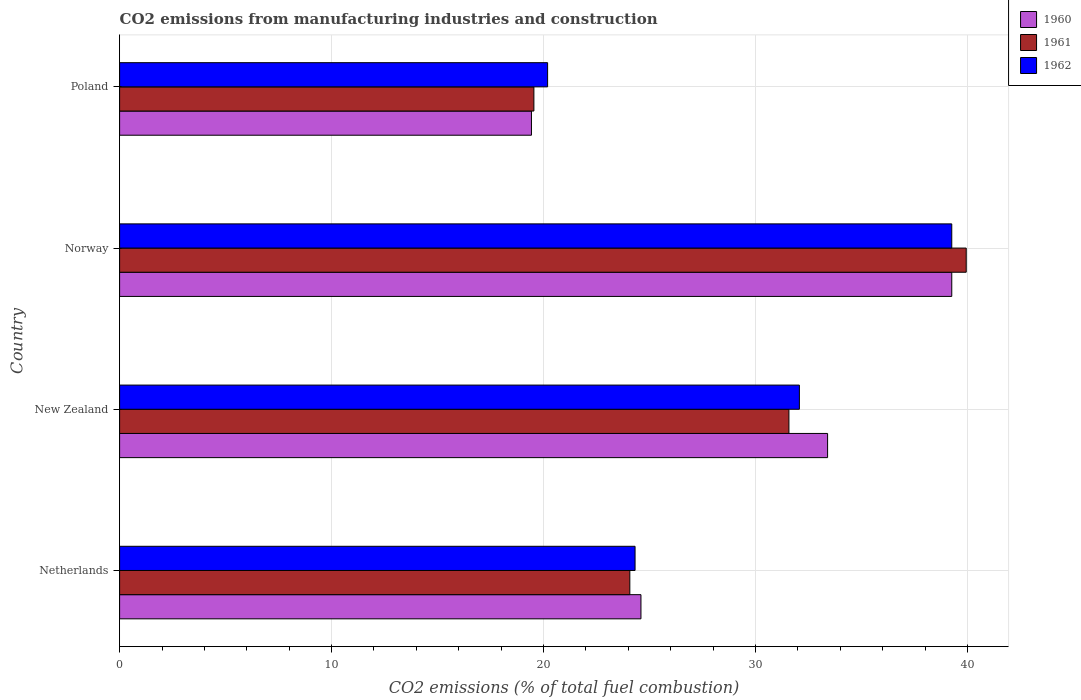How many different coloured bars are there?
Give a very brief answer. 3. How many groups of bars are there?
Your answer should be very brief. 4. How many bars are there on the 4th tick from the top?
Your answer should be compact. 3. In how many cases, is the number of bars for a given country not equal to the number of legend labels?
Offer a terse response. 0. What is the amount of CO2 emitted in 1960 in New Zealand?
Your answer should be compact. 33.4. Across all countries, what is the maximum amount of CO2 emitted in 1961?
Offer a terse response. 39.94. Across all countries, what is the minimum amount of CO2 emitted in 1960?
Make the answer very short. 19.43. In which country was the amount of CO2 emitted in 1961 maximum?
Ensure brevity in your answer.  Norway. In which country was the amount of CO2 emitted in 1962 minimum?
Keep it short and to the point. Poland. What is the total amount of CO2 emitted in 1962 in the graph?
Your response must be concise. 115.83. What is the difference between the amount of CO2 emitted in 1961 in Netherlands and that in New Zealand?
Offer a terse response. -7.5. What is the difference between the amount of CO2 emitted in 1962 in Poland and the amount of CO2 emitted in 1960 in Netherlands?
Offer a very short reply. -4.4. What is the average amount of CO2 emitted in 1962 per country?
Give a very brief answer. 28.96. What is the difference between the amount of CO2 emitted in 1962 and amount of CO2 emitted in 1960 in Poland?
Provide a short and direct response. 0.76. In how many countries, is the amount of CO2 emitted in 1960 greater than 6 %?
Ensure brevity in your answer.  4. What is the ratio of the amount of CO2 emitted in 1960 in Netherlands to that in New Zealand?
Give a very brief answer. 0.74. Is the difference between the amount of CO2 emitted in 1962 in Norway and Poland greater than the difference between the amount of CO2 emitted in 1960 in Norway and Poland?
Give a very brief answer. No. What is the difference between the highest and the second highest amount of CO2 emitted in 1960?
Keep it short and to the point. 5.86. What is the difference between the highest and the lowest amount of CO2 emitted in 1962?
Keep it short and to the point. 19.06. In how many countries, is the amount of CO2 emitted in 1962 greater than the average amount of CO2 emitted in 1962 taken over all countries?
Make the answer very short. 2. Is the sum of the amount of CO2 emitted in 1961 in New Zealand and Norway greater than the maximum amount of CO2 emitted in 1962 across all countries?
Offer a very short reply. Yes. What does the 1st bar from the bottom in Poland represents?
Ensure brevity in your answer.  1960. Is it the case that in every country, the sum of the amount of CO2 emitted in 1961 and amount of CO2 emitted in 1962 is greater than the amount of CO2 emitted in 1960?
Provide a short and direct response. Yes. How many bars are there?
Provide a succinct answer. 12. Are all the bars in the graph horizontal?
Your answer should be very brief. Yes. What is the difference between two consecutive major ticks on the X-axis?
Offer a very short reply. 10. Does the graph contain any zero values?
Your response must be concise. No. How are the legend labels stacked?
Give a very brief answer. Vertical. What is the title of the graph?
Give a very brief answer. CO2 emissions from manufacturing industries and construction. Does "1998" appear as one of the legend labels in the graph?
Make the answer very short. No. What is the label or title of the X-axis?
Make the answer very short. CO2 emissions (% of total fuel combustion). What is the label or title of the Y-axis?
Provide a short and direct response. Country. What is the CO2 emissions (% of total fuel combustion) of 1960 in Netherlands?
Your response must be concise. 24.59. What is the CO2 emissions (% of total fuel combustion) in 1961 in Netherlands?
Ensure brevity in your answer.  24.07. What is the CO2 emissions (% of total fuel combustion) in 1962 in Netherlands?
Make the answer very short. 24.32. What is the CO2 emissions (% of total fuel combustion) in 1960 in New Zealand?
Offer a terse response. 33.4. What is the CO2 emissions (% of total fuel combustion) in 1961 in New Zealand?
Provide a short and direct response. 31.57. What is the CO2 emissions (% of total fuel combustion) in 1962 in New Zealand?
Make the answer very short. 32.07. What is the CO2 emissions (% of total fuel combustion) of 1960 in Norway?
Make the answer very short. 39.26. What is the CO2 emissions (% of total fuel combustion) in 1961 in Norway?
Provide a short and direct response. 39.94. What is the CO2 emissions (% of total fuel combustion) of 1962 in Norway?
Provide a short and direct response. 39.26. What is the CO2 emissions (% of total fuel combustion) in 1960 in Poland?
Provide a succinct answer. 19.43. What is the CO2 emissions (% of total fuel combustion) in 1961 in Poland?
Keep it short and to the point. 19.54. What is the CO2 emissions (% of total fuel combustion) in 1962 in Poland?
Ensure brevity in your answer.  20.19. Across all countries, what is the maximum CO2 emissions (% of total fuel combustion) in 1960?
Your answer should be very brief. 39.26. Across all countries, what is the maximum CO2 emissions (% of total fuel combustion) of 1961?
Your answer should be compact. 39.94. Across all countries, what is the maximum CO2 emissions (% of total fuel combustion) of 1962?
Your answer should be very brief. 39.26. Across all countries, what is the minimum CO2 emissions (% of total fuel combustion) of 1960?
Provide a succinct answer. 19.43. Across all countries, what is the minimum CO2 emissions (% of total fuel combustion) of 1961?
Ensure brevity in your answer.  19.54. Across all countries, what is the minimum CO2 emissions (% of total fuel combustion) in 1962?
Provide a short and direct response. 20.19. What is the total CO2 emissions (% of total fuel combustion) in 1960 in the graph?
Keep it short and to the point. 116.68. What is the total CO2 emissions (% of total fuel combustion) of 1961 in the graph?
Keep it short and to the point. 115.12. What is the total CO2 emissions (% of total fuel combustion) of 1962 in the graph?
Keep it short and to the point. 115.83. What is the difference between the CO2 emissions (% of total fuel combustion) in 1960 in Netherlands and that in New Zealand?
Give a very brief answer. -8.8. What is the difference between the CO2 emissions (% of total fuel combustion) of 1961 in Netherlands and that in New Zealand?
Your response must be concise. -7.5. What is the difference between the CO2 emissions (% of total fuel combustion) in 1962 in Netherlands and that in New Zealand?
Make the answer very short. -7.75. What is the difference between the CO2 emissions (% of total fuel combustion) of 1960 in Netherlands and that in Norway?
Your answer should be very brief. -14.66. What is the difference between the CO2 emissions (% of total fuel combustion) of 1961 in Netherlands and that in Norway?
Make the answer very short. -15.87. What is the difference between the CO2 emissions (% of total fuel combustion) in 1962 in Netherlands and that in Norway?
Your response must be concise. -14.94. What is the difference between the CO2 emissions (% of total fuel combustion) of 1960 in Netherlands and that in Poland?
Make the answer very short. 5.17. What is the difference between the CO2 emissions (% of total fuel combustion) in 1961 in Netherlands and that in Poland?
Your answer should be very brief. 4.53. What is the difference between the CO2 emissions (% of total fuel combustion) in 1962 in Netherlands and that in Poland?
Ensure brevity in your answer.  4.13. What is the difference between the CO2 emissions (% of total fuel combustion) of 1960 in New Zealand and that in Norway?
Offer a very short reply. -5.86. What is the difference between the CO2 emissions (% of total fuel combustion) of 1961 in New Zealand and that in Norway?
Offer a terse response. -8.36. What is the difference between the CO2 emissions (% of total fuel combustion) of 1962 in New Zealand and that in Norway?
Offer a very short reply. -7.19. What is the difference between the CO2 emissions (% of total fuel combustion) in 1960 in New Zealand and that in Poland?
Your answer should be compact. 13.97. What is the difference between the CO2 emissions (% of total fuel combustion) in 1961 in New Zealand and that in Poland?
Your answer should be compact. 12.03. What is the difference between the CO2 emissions (% of total fuel combustion) of 1962 in New Zealand and that in Poland?
Offer a very short reply. 11.88. What is the difference between the CO2 emissions (% of total fuel combustion) in 1960 in Norway and that in Poland?
Provide a succinct answer. 19.83. What is the difference between the CO2 emissions (% of total fuel combustion) of 1961 in Norway and that in Poland?
Provide a succinct answer. 20.39. What is the difference between the CO2 emissions (% of total fuel combustion) of 1962 in Norway and that in Poland?
Give a very brief answer. 19.06. What is the difference between the CO2 emissions (% of total fuel combustion) in 1960 in Netherlands and the CO2 emissions (% of total fuel combustion) in 1961 in New Zealand?
Make the answer very short. -6.98. What is the difference between the CO2 emissions (% of total fuel combustion) of 1960 in Netherlands and the CO2 emissions (% of total fuel combustion) of 1962 in New Zealand?
Your response must be concise. -7.47. What is the difference between the CO2 emissions (% of total fuel combustion) in 1961 in Netherlands and the CO2 emissions (% of total fuel combustion) in 1962 in New Zealand?
Your response must be concise. -8. What is the difference between the CO2 emissions (% of total fuel combustion) of 1960 in Netherlands and the CO2 emissions (% of total fuel combustion) of 1961 in Norway?
Your response must be concise. -15.34. What is the difference between the CO2 emissions (% of total fuel combustion) in 1960 in Netherlands and the CO2 emissions (% of total fuel combustion) in 1962 in Norway?
Your answer should be compact. -14.66. What is the difference between the CO2 emissions (% of total fuel combustion) of 1961 in Netherlands and the CO2 emissions (% of total fuel combustion) of 1962 in Norway?
Offer a terse response. -15.19. What is the difference between the CO2 emissions (% of total fuel combustion) of 1960 in Netherlands and the CO2 emissions (% of total fuel combustion) of 1961 in Poland?
Make the answer very short. 5.05. What is the difference between the CO2 emissions (% of total fuel combustion) of 1960 in Netherlands and the CO2 emissions (% of total fuel combustion) of 1962 in Poland?
Your answer should be compact. 4.4. What is the difference between the CO2 emissions (% of total fuel combustion) of 1961 in Netherlands and the CO2 emissions (% of total fuel combustion) of 1962 in Poland?
Make the answer very short. 3.88. What is the difference between the CO2 emissions (% of total fuel combustion) of 1960 in New Zealand and the CO2 emissions (% of total fuel combustion) of 1961 in Norway?
Give a very brief answer. -6.54. What is the difference between the CO2 emissions (% of total fuel combustion) in 1960 in New Zealand and the CO2 emissions (% of total fuel combustion) in 1962 in Norway?
Make the answer very short. -5.86. What is the difference between the CO2 emissions (% of total fuel combustion) of 1961 in New Zealand and the CO2 emissions (% of total fuel combustion) of 1962 in Norway?
Offer a terse response. -7.68. What is the difference between the CO2 emissions (% of total fuel combustion) of 1960 in New Zealand and the CO2 emissions (% of total fuel combustion) of 1961 in Poland?
Provide a short and direct response. 13.85. What is the difference between the CO2 emissions (% of total fuel combustion) of 1960 in New Zealand and the CO2 emissions (% of total fuel combustion) of 1962 in Poland?
Your answer should be very brief. 13.21. What is the difference between the CO2 emissions (% of total fuel combustion) of 1961 in New Zealand and the CO2 emissions (% of total fuel combustion) of 1962 in Poland?
Ensure brevity in your answer.  11.38. What is the difference between the CO2 emissions (% of total fuel combustion) in 1960 in Norway and the CO2 emissions (% of total fuel combustion) in 1961 in Poland?
Offer a terse response. 19.71. What is the difference between the CO2 emissions (% of total fuel combustion) of 1960 in Norway and the CO2 emissions (% of total fuel combustion) of 1962 in Poland?
Provide a short and direct response. 19.06. What is the difference between the CO2 emissions (% of total fuel combustion) in 1961 in Norway and the CO2 emissions (% of total fuel combustion) in 1962 in Poland?
Offer a terse response. 19.75. What is the average CO2 emissions (% of total fuel combustion) of 1960 per country?
Offer a very short reply. 29.17. What is the average CO2 emissions (% of total fuel combustion) of 1961 per country?
Offer a very short reply. 28.78. What is the average CO2 emissions (% of total fuel combustion) in 1962 per country?
Your answer should be very brief. 28.96. What is the difference between the CO2 emissions (% of total fuel combustion) of 1960 and CO2 emissions (% of total fuel combustion) of 1961 in Netherlands?
Your response must be concise. 0.52. What is the difference between the CO2 emissions (% of total fuel combustion) of 1960 and CO2 emissions (% of total fuel combustion) of 1962 in Netherlands?
Your response must be concise. 0.28. What is the difference between the CO2 emissions (% of total fuel combustion) of 1961 and CO2 emissions (% of total fuel combustion) of 1962 in Netherlands?
Keep it short and to the point. -0.25. What is the difference between the CO2 emissions (% of total fuel combustion) in 1960 and CO2 emissions (% of total fuel combustion) in 1961 in New Zealand?
Give a very brief answer. 1.82. What is the difference between the CO2 emissions (% of total fuel combustion) in 1960 and CO2 emissions (% of total fuel combustion) in 1962 in New Zealand?
Offer a very short reply. 1.33. What is the difference between the CO2 emissions (% of total fuel combustion) in 1961 and CO2 emissions (% of total fuel combustion) in 1962 in New Zealand?
Ensure brevity in your answer.  -0.49. What is the difference between the CO2 emissions (% of total fuel combustion) in 1960 and CO2 emissions (% of total fuel combustion) in 1961 in Norway?
Offer a very short reply. -0.68. What is the difference between the CO2 emissions (% of total fuel combustion) of 1960 and CO2 emissions (% of total fuel combustion) of 1962 in Norway?
Your answer should be very brief. 0. What is the difference between the CO2 emissions (% of total fuel combustion) of 1961 and CO2 emissions (% of total fuel combustion) of 1962 in Norway?
Your answer should be compact. 0.68. What is the difference between the CO2 emissions (% of total fuel combustion) of 1960 and CO2 emissions (% of total fuel combustion) of 1961 in Poland?
Your answer should be very brief. -0.11. What is the difference between the CO2 emissions (% of total fuel combustion) of 1960 and CO2 emissions (% of total fuel combustion) of 1962 in Poland?
Your answer should be compact. -0.76. What is the difference between the CO2 emissions (% of total fuel combustion) of 1961 and CO2 emissions (% of total fuel combustion) of 1962 in Poland?
Offer a terse response. -0.65. What is the ratio of the CO2 emissions (% of total fuel combustion) of 1960 in Netherlands to that in New Zealand?
Make the answer very short. 0.74. What is the ratio of the CO2 emissions (% of total fuel combustion) in 1961 in Netherlands to that in New Zealand?
Offer a terse response. 0.76. What is the ratio of the CO2 emissions (% of total fuel combustion) of 1962 in Netherlands to that in New Zealand?
Provide a short and direct response. 0.76. What is the ratio of the CO2 emissions (% of total fuel combustion) in 1960 in Netherlands to that in Norway?
Ensure brevity in your answer.  0.63. What is the ratio of the CO2 emissions (% of total fuel combustion) of 1961 in Netherlands to that in Norway?
Offer a terse response. 0.6. What is the ratio of the CO2 emissions (% of total fuel combustion) in 1962 in Netherlands to that in Norway?
Keep it short and to the point. 0.62. What is the ratio of the CO2 emissions (% of total fuel combustion) in 1960 in Netherlands to that in Poland?
Provide a short and direct response. 1.27. What is the ratio of the CO2 emissions (% of total fuel combustion) in 1961 in Netherlands to that in Poland?
Make the answer very short. 1.23. What is the ratio of the CO2 emissions (% of total fuel combustion) of 1962 in Netherlands to that in Poland?
Make the answer very short. 1.2. What is the ratio of the CO2 emissions (% of total fuel combustion) in 1960 in New Zealand to that in Norway?
Provide a succinct answer. 0.85. What is the ratio of the CO2 emissions (% of total fuel combustion) of 1961 in New Zealand to that in Norway?
Make the answer very short. 0.79. What is the ratio of the CO2 emissions (% of total fuel combustion) of 1962 in New Zealand to that in Norway?
Provide a short and direct response. 0.82. What is the ratio of the CO2 emissions (% of total fuel combustion) of 1960 in New Zealand to that in Poland?
Your response must be concise. 1.72. What is the ratio of the CO2 emissions (% of total fuel combustion) of 1961 in New Zealand to that in Poland?
Offer a terse response. 1.62. What is the ratio of the CO2 emissions (% of total fuel combustion) in 1962 in New Zealand to that in Poland?
Keep it short and to the point. 1.59. What is the ratio of the CO2 emissions (% of total fuel combustion) in 1960 in Norway to that in Poland?
Provide a succinct answer. 2.02. What is the ratio of the CO2 emissions (% of total fuel combustion) in 1961 in Norway to that in Poland?
Offer a very short reply. 2.04. What is the ratio of the CO2 emissions (% of total fuel combustion) in 1962 in Norway to that in Poland?
Offer a terse response. 1.94. What is the difference between the highest and the second highest CO2 emissions (% of total fuel combustion) in 1960?
Ensure brevity in your answer.  5.86. What is the difference between the highest and the second highest CO2 emissions (% of total fuel combustion) of 1961?
Offer a very short reply. 8.36. What is the difference between the highest and the second highest CO2 emissions (% of total fuel combustion) of 1962?
Make the answer very short. 7.19. What is the difference between the highest and the lowest CO2 emissions (% of total fuel combustion) in 1960?
Your answer should be compact. 19.83. What is the difference between the highest and the lowest CO2 emissions (% of total fuel combustion) of 1961?
Give a very brief answer. 20.39. What is the difference between the highest and the lowest CO2 emissions (% of total fuel combustion) of 1962?
Your answer should be compact. 19.06. 